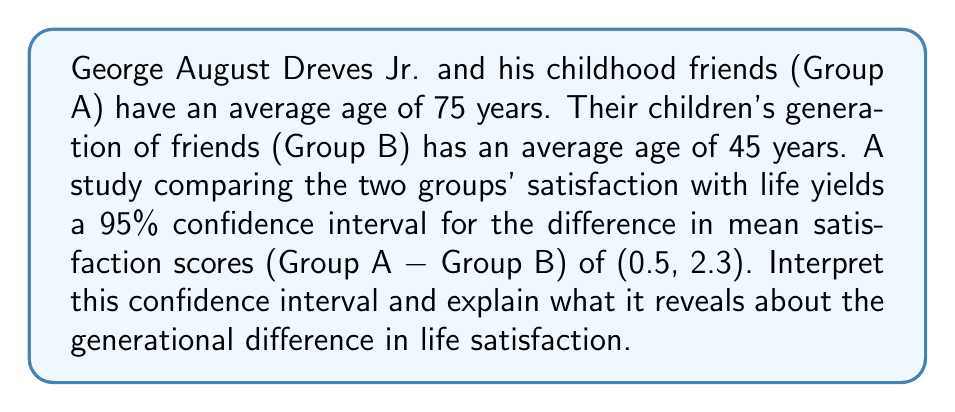Teach me how to tackle this problem. To interpret this confidence interval, let's break it down step-by-step:

1) The confidence interval is given as (0.5, 2.3) for the difference in mean satisfaction scores (Group A - Group B).

2) This interval is entirely positive, which means:
   $$0.5 < \mu_A - \mu_B < 2.3$$
   where $\mu_A$ and $\mu_B$ are the true population means for Group A and Group B respectively.

3) The fact that both bounds are positive indicates that we can be 95% confident that the true difference in population means is positive.

4) This suggests that Group A (George and his friends) likely has a higher average satisfaction score than Group B (their children's generation).

5) The lower bound of 0.5 indicates that we can be 95% confident that Group A's mean satisfaction score is at least 0.5 points higher than Group B's.

6) The upper bound of 2.3 suggests that the difference could be as large as 2.3 points in favor of Group A.

7) Since this is a 95% confidence interval, there's a 5% chance that the true population difference falls outside this range.

8) The interval doesn't include 0, which means the difference is statistically significant at the 5% level.

This result suggests a generational difference in life satisfaction, with the older generation (George and his friends) reporting higher satisfaction levels than the younger generation.
Answer: The older generation likely has higher life satisfaction, with 95% confidence that their mean score is 0.5 to 2.3 points higher than the younger generation's. 